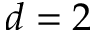Convert formula to latex. <formula><loc_0><loc_0><loc_500><loc_500>d = 2</formula> 